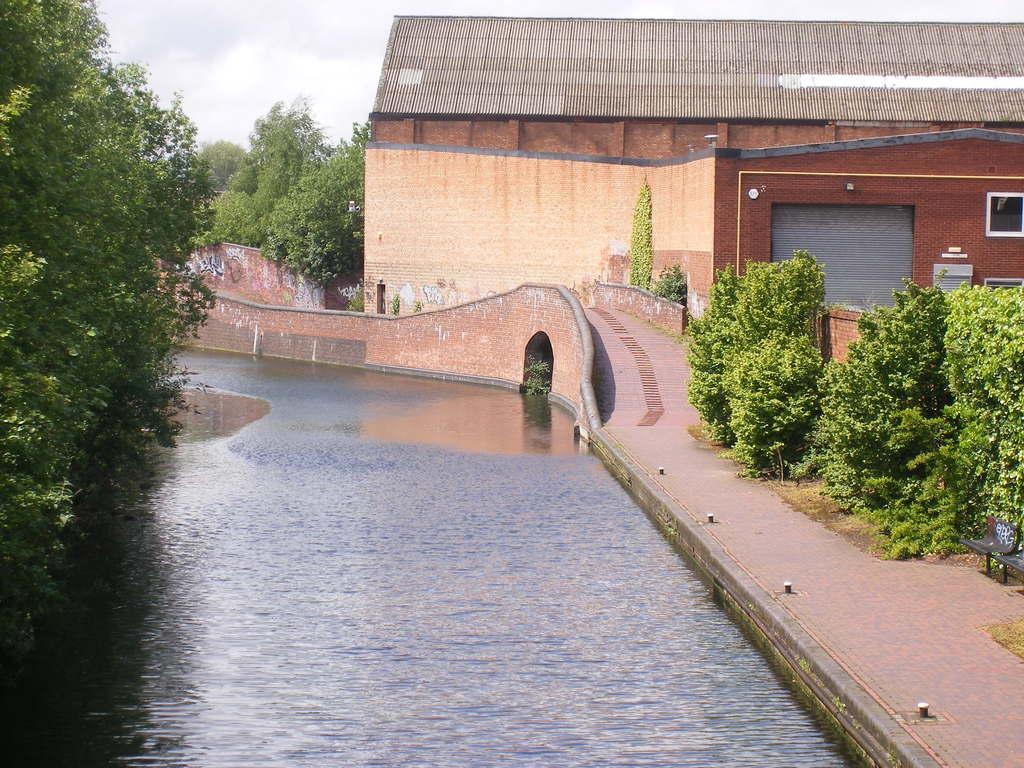Please provide a concise description of this image. There is water of a lake. On the left side, there are trees. On the right side, there is a footpath near plants and wall. In the background, there is a building which is having roof and shutter, there are trees, a bridge, walls and clouds in the blue sky. 